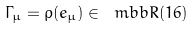<formula> <loc_0><loc_0><loc_500><loc_500>\Gamma _ { \mu } = \rho ( e _ { \mu } ) \in \ m b b R ( 1 6 )</formula> 